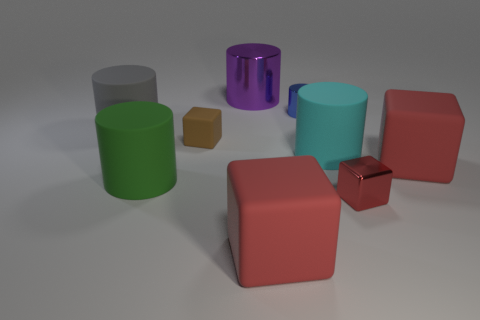What material is the large purple object?
Provide a short and direct response. Metal. The metal cube has what color?
Your response must be concise. Red. What is the color of the big object that is in front of the big purple cylinder and behind the brown rubber thing?
Your answer should be very brief. Gray. Is there anything else that is the same material as the purple cylinder?
Your response must be concise. Yes. Are the small blue thing and the small thing that is in front of the brown block made of the same material?
Your response must be concise. Yes. How big is the red matte thing that is right of the metallic object in front of the gray cylinder?
Ensure brevity in your answer.  Large. Is there any other thing that has the same color as the small metallic block?
Your answer should be compact. Yes. Are the object right of the small red shiny cube and the tiny brown block that is in front of the blue metallic object made of the same material?
Keep it short and to the point. Yes. There is a big cylinder that is both left of the big metallic cylinder and behind the small brown matte cube; what is it made of?
Give a very brief answer. Rubber. Do the gray matte thing and the large rubber object in front of the small red metallic object have the same shape?
Provide a succinct answer. No. 